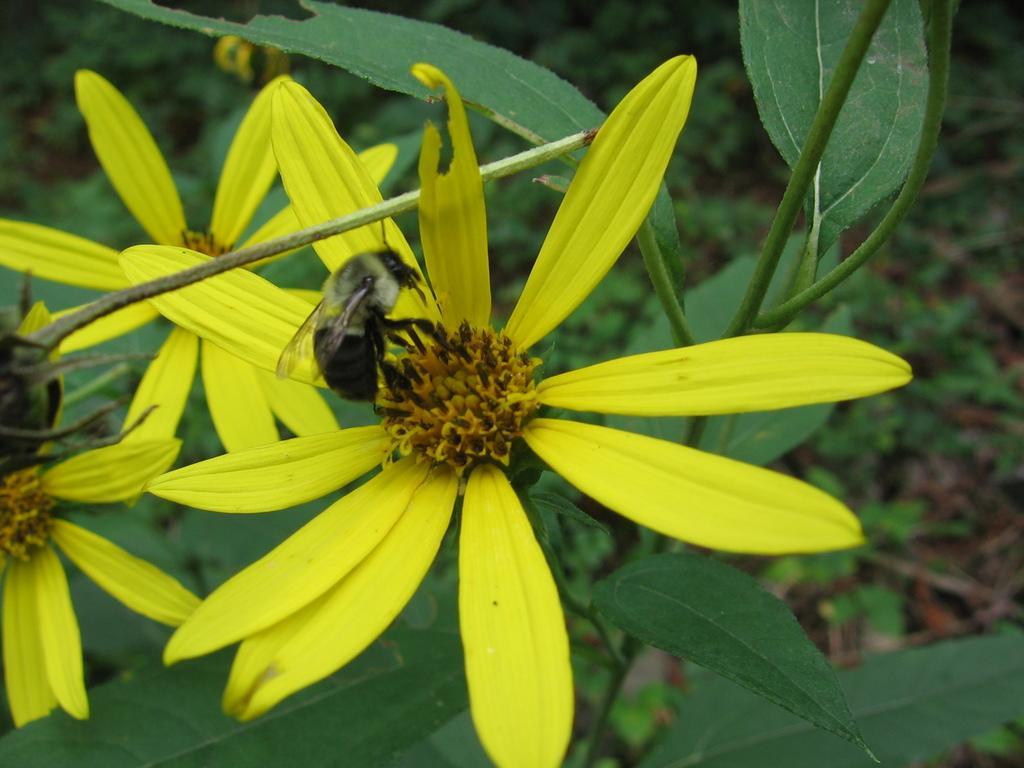Could you give a brief overview of what you see in this image? In this image, in the middle, we can see an insect which is on the flower and the flower is in yellow color. In the background, we can see some plants with green leaves. 